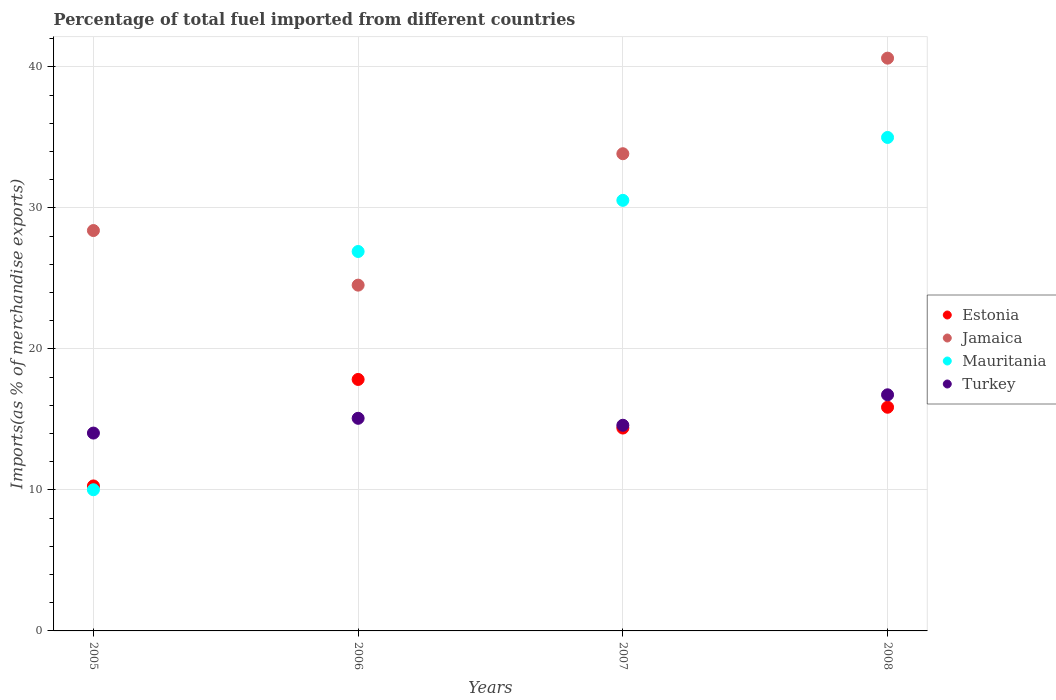What is the percentage of imports to different countries in Estonia in 2006?
Give a very brief answer. 17.83. Across all years, what is the maximum percentage of imports to different countries in Jamaica?
Your answer should be very brief. 40.62. Across all years, what is the minimum percentage of imports to different countries in Jamaica?
Your answer should be compact. 24.52. In which year was the percentage of imports to different countries in Jamaica maximum?
Make the answer very short. 2008. What is the total percentage of imports to different countries in Jamaica in the graph?
Keep it short and to the point. 127.37. What is the difference between the percentage of imports to different countries in Mauritania in 2005 and that in 2007?
Your answer should be very brief. -20.52. What is the difference between the percentage of imports to different countries in Turkey in 2005 and the percentage of imports to different countries in Mauritania in 2008?
Ensure brevity in your answer.  -20.96. What is the average percentage of imports to different countries in Estonia per year?
Give a very brief answer. 14.59. In the year 2007, what is the difference between the percentage of imports to different countries in Mauritania and percentage of imports to different countries in Estonia?
Ensure brevity in your answer.  16.15. What is the ratio of the percentage of imports to different countries in Mauritania in 2006 to that in 2008?
Your answer should be very brief. 0.77. Is the percentage of imports to different countries in Mauritania in 2005 less than that in 2008?
Make the answer very short. Yes. Is the difference between the percentage of imports to different countries in Mauritania in 2006 and 2008 greater than the difference between the percentage of imports to different countries in Estonia in 2006 and 2008?
Give a very brief answer. No. What is the difference between the highest and the second highest percentage of imports to different countries in Turkey?
Ensure brevity in your answer.  1.67. What is the difference between the highest and the lowest percentage of imports to different countries in Turkey?
Give a very brief answer. 2.71. Is it the case that in every year, the sum of the percentage of imports to different countries in Jamaica and percentage of imports to different countries in Turkey  is greater than the sum of percentage of imports to different countries in Mauritania and percentage of imports to different countries in Estonia?
Your answer should be compact. Yes. Is it the case that in every year, the sum of the percentage of imports to different countries in Estonia and percentage of imports to different countries in Turkey  is greater than the percentage of imports to different countries in Mauritania?
Keep it short and to the point. No. Is the percentage of imports to different countries in Estonia strictly less than the percentage of imports to different countries in Mauritania over the years?
Give a very brief answer. No. How many dotlines are there?
Make the answer very short. 4. How many years are there in the graph?
Provide a succinct answer. 4. Does the graph contain any zero values?
Provide a short and direct response. No. Does the graph contain grids?
Offer a very short reply. Yes. What is the title of the graph?
Your answer should be very brief. Percentage of total fuel imported from different countries. What is the label or title of the X-axis?
Offer a terse response. Years. What is the label or title of the Y-axis?
Keep it short and to the point. Imports(as % of merchandise exports). What is the Imports(as % of merchandise exports) of Estonia in 2005?
Your answer should be very brief. 10.28. What is the Imports(as % of merchandise exports) in Jamaica in 2005?
Offer a very short reply. 28.39. What is the Imports(as % of merchandise exports) in Mauritania in 2005?
Offer a very short reply. 10.01. What is the Imports(as % of merchandise exports) in Turkey in 2005?
Offer a terse response. 14.03. What is the Imports(as % of merchandise exports) in Estonia in 2006?
Your response must be concise. 17.83. What is the Imports(as % of merchandise exports) in Jamaica in 2006?
Give a very brief answer. 24.52. What is the Imports(as % of merchandise exports) in Mauritania in 2006?
Provide a succinct answer. 26.91. What is the Imports(as % of merchandise exports) in Turkey in 2006?
Ensure brevity in your answer.  15.08. What is the Imports(as % of merchandise exports) of Estonia in 2007?
Offer a terse response. 14.39. What is the Imports(as % of merchandise exports) in Jamaica in 2007?
Your answer should be very brief. 33.84. What is the Imports(as % of merchandise exports) of Mauritania in 2007?
Keep it short and to the point. 30.53. What is the Imports(as % of merchandise exports) in Turkey in 2007?
Give a very brief answer. 14.58. What is the Imports(as % of merchandise exports) of Estonia in 2008?
Keep it short and to the point. 15.86. What is the Imports(as % of merchandise exports) in Jamaica in 2008?
Make the answer very short. 40.62. What is the Imports(as % of merchandise exports) of Mauritania in 2008?
Ensure brevity in your answer.  34.99. What is the Imports(as % of merchandise exports) in Turkey in 2008?
Give a very brief answer. 16.74. Across all years, what is the maximum Imports(as % of merchandise exports) in Estonia?
Provide a short and direct response. 17.83. Across all years, what is the maximum Imports(as % of merchandise exports) in Jamaica?
Your response must be concise. 40.62. Across all years, what is the maximum Imports(as % of merchandise exports) of Mauritania?
Keep it short and to the point. 34.99. Across all years, what is the maximum Imports(as % of merchandise exports) in Turkey?
Your answer should be compact. 16.74. Across all years, what is the minimum Imports(as % of merchandise exports) in Estonia?
Keep it short and to the point. 10.28. Across all years, what is the minimum Imports(as % of merchandise exports) in Jamaica?
Ensure brevity in your answer.  24.52. Across all years, what is the minimum Imports(as % of merchandise exports) in Mauritania?
Your response must be concise. 10.01. Across all years, what is the minimum Imports(as % of merchandise exports) in Turkey?
Your answer should be compact. 14.03. What is the total Imports(as % of merchandise exports) of Estonia in the graph?
Offer a terse response. 58.36. What is the total Imports(as % of merchandise exports) in Jamaica in the graph?
Offer a terse response. 127.37. What is the total Imports(as % of merchandise exports) of Mauritania in the graph?
Offer a terse response. 102.44. What is the total Imports(as % of merchandise exports) in Turkey in the graph?
Your response must be concise. 60.44. What is the difference between the Imports(as % of merchandise exports) of Estonia in 2005 and that in 2006?
Give a very brief answer. -7.55. What is the difference between the Imports(as % of merchandise exports) of Jamaica in 2005 and that in 2006?
Give a very brief answer. 3.87. What is the difference between the Imports(as % of merchandise exports) of Mauritania in 2005 and that in 2006?
Ensure brevity in your answer.  -16.9. What is the difference between the Imports(as % of merchandise exports) in Turkey in 2005 and that in 2006?
Your response must be concise. -1.05. What is the difference between the Imports(as % of merchandise exports) in Estonia in 2005 and that in 2007?
Your answer should be very brief. -4.11. What is the difference between the Imports(as % of merchandise exports) of Jamaica in 2005 and that in 2007?
Make the answer very short. -5.45. What is the difference between the Imports(as % of merchandise exports) of Mauritania in 2005 and that in 2007?
Offer a terse response. -20.52. What is the difference between the Imports(as % of merchandise exports) in Turkey in 2005 and that in 2007?
Give a very brief answer. -0.55. What is the difference between the Imports(as % of merchandise exports) in Estonia in 2005 and that in 2008?
Give a very brief answer. -5.58. What is the difference between the Imports(as % of merchandise exports) in Jamaica in 2005 and that in 2008?
Offer a terse response. -12.22. What is the difference between the Imports(as % of merchandise exports) in Mauritania in 2005 and that in 2008?
Your response must be concise. -24.98. What is the difference between the Imports(as % of merchandise exports) in Turkey in 2005 and that in 2008?
Offer a terse response. -2.71. What is the difference between the Imports(as % of merchandise exports) of Estonia in 2006 and that in 2007?
Make the answer very short. 3.45. What is the difference between the Imports(as % of merchandise exports) in Jamaica in 2006 and that in 2007?
Your answer should be very brief. -9.32. What is the difference between the Imports(as % of merchandise exports) in Mauritania in 2006 and that in 2007?
Give a very brief answer. -3.63. What is the difference between the Imports(as % of merchandise exports) in Turkey in 2006 and that in 2007?
Offer a terse response. 0.49. What is the difference between the Imports(as % of merchandise exports) in Estonia in 2006 and that in 2008?
Your answer should be very brief. 1.97. What is the difference between the Imports(as % of merchandise exports) in Jamaica in 2006 and that in 2008?
Make the answer very short. -16.1. What is the difference between the Imports(as % of merchandise exports) of Mauritania in 2006 and that in 2008?
Your response must be concise. -8.09. What is the difference between the Imports(as % of merchandise exports) of Turkey in 2006 and that in 2008?
Your answer should be compact. -1.67. What is the difference between the Imports(as % of merchandise exports) in Estonia in 2007 and that in 2008?
Your answer should be compact. -1.48. What is the difference between the Imports(as % of merchandise exports) in Jamaica in 2007 and that in 2008?
Ensure brevity in your answer.  -6.78. What is the difference between the Imports(as % of merchandise exports) in Mauritania in 2007 and that in 2008?
Give a very brief answer. -4.46. What is the difference between the Imports(as % of merchandise exports) in Turkey in 2007 and that in 2008?
Provide a short and direct response. -2.16. What is the difference between the Imports(as % of merchandise exports) in Estonia in 2005 and the Imports(as % of merchandise exports) in Jamaica in 2006?
Ensure brevity in your answer.  -14.24. What is the difference between the Imports(as % of merchandise exports) of Estonia in 2005 and the Imports(as % of merchandise exports) of Mauritania in 2006?
Provide a succinct answer. -16.63. What is the difference between the Imports(as % of merchandise exports) of Estonia in 2005 and the Imports(as % of merchandise exports) of Turkey in 2006?
Your answer should be very brief. -4.8. What is the difference between the Imports(as % of merchandise exports) in Jamaica in 2005 and the Imports(as % of merchandise exports) in Mauritania in 2006?
Your response must be concise. 1.49. What is the difference between the Imports(as % of merchandise exports) of Jamaica in 2005 and the Imports(as % of merchandise exports) of Turkey in 2006?
Keep it short and to the point. 13.31. What is the difference between the Imports(as % of merchandise exports) in Mauritania in 2005 and the Imports(as % of merchandise exports) in Turkey in 2006?
Offer a terse response. -5.07. What is the difference between the Imports(as % of merchandise exports) in Estonia in 2005 and the Imports(as % of merchandise exports) in Jamaica in 2007?
Provide a short and direct response. -23.56. What is the difference between the Imports(as % of merchandise exports) of Estonia in 2005 and the Imports(as % of merchandise exports) of Mauritania in 2007?
Your response must be concise. -20.25. What is the difference between the Imports(as % of merchandise exports) in Estonia in 2005 and the Imports(as % of merchandise exports) in Turkey in 2007?
Your response must be concise. -4.3. What is the difference between the Imports(as % of merchandise exports) in Jamaica in 2005 and the Imports(as % of merchandise exports) in Mauritania in 2007?
Provide a short and direct response. -2.14. What is the difference between the Imports(as % of merchandise exports) in Jamaica in 2005 and the Imports(as % of merchandise exports) in Turkey in 2007?
Offer a terse response. 13.81. What is the difference between the Imports(as % of merchandise exports) of Mauritania in 2005 and the Imports(as % of merchandise exports) of Turkey in 2007?
Give a very brief answer. -4.57. What is the difference between the Imports(as % of merchandise exports) in Estonia in 2005 and the Imports(as % of merchandise exports) in Jamaica in 2008?
Your answer should be compact. -30.34. What is the difference between the Imports(as % of merchandise exports) in Estonia in 2005 and the Imports(as % of merchandise exports) in Mauritania in 2008?
Your answer should be very brief. -24.71. What is the difference between the Imports(as % of merchandise exports) in Estonia in 2005 and the Imports(as % of merchandise exports) in Turkey in 2008?
Give a very brief answer. -6.46. What is the difference between the Imports(as % of merchandise exports) in Jamaica in 2005 and the Imports(as % of merchandise exports) in Mauritania in 2008?
Offer a terse response. -6.6. What is the difference between the Imports(as % of merchandise exports) of Jamaica in 2005 and the Imports(as % of merchandise exports) of Turkey in 2008?
Make the answer very short. 11.65. What is the difference between the Imports(as % of merchandise exports) in Mauritania in 2005 and the Imports(as % of merchandise exports) in Turkey in 2008?
Your response must be concise. -6.73. What is the difference between the Imports(as % of merchandise exports) in Estonia in 2006 and the Imports(as % of merchandise exports) in Jamaica in 2007?
Ensure brevity in your answer.  -16.01. What is the difference between the Imports(as % of merchandise exports) of Estonia in 2006 and the Imports(as % of merchandise exports) of Mauritania in 2007?
Keep it short and to the point. -12.7. What is the difference between the Imports(as % of merchandise exports) of Estonia in 2006 and the Imports(as % of merchandise exports) of Turkey in 2007?
Provide a succinct answer. 3.25. What is the difference between the Imports(as % of merchandise exports) of Jamaica in 2006 and the Imports(as % of merchandise exports) of Mauritania in 2007?
Provide a short and direct response. -6.01. What is the difference between the Imports(as % of merchandise exports) in Jamaica in 2006 and the Imports(as % of merchandise exports) in Turkey in 2007?
Offer a terse response. 9.94. What is the difference between the Imports(as % of merchandise exports) of Mauritania in 2006 and the Imports(as % of merchandise exports) of Turkey in 2007?
Ensure brevity in your answer.  12.32. What is the difference between the Imports(as % of merchandise exports) in Estonia in 2006 and the Imports(as % of merchandise exports) in Jamaica in 2008?
Provide a succinct answer. -22.78. What is the difference between the Imports(as % of merchandise exports) in Estonia in 2006 and the Imports(as % of merchandise exports) in Mauritania in 2008?
Your answer should be very brief. -17.16. What is the difference between the Imports(as % of merchandise exports) in Estonia in 2006 and the Imports(as % of merchandise exports) in Turkey in 2008?
Your response must be concise. 1.09. What is the difference between the Imports(as % of merchandise exports) in Jamaica in 2006 and the Imports(as % of merchandise exports) in Mauritania in 2008?
Ensure brevity in your answer.  -10.47. What is the difference between the Imports(as % of merchandise exports) in Jamaica in 2006 and the Imports(as % of merchandise exports) in Turkey in 2008?
Make the answer very short. 7.78. What is the difference between the Imports(as % of merchandise exports) of Mauritania in 2006 and the Imports(as % of merchandise exports) of Turkey in 2008?
Offer a terse response. 10.16. What is the difference between the Imports(as % of merchandise exports) in Estonia in 2007 and the Imports(as % of merchandise exports) in Jamaica in 2008?
Provide a short and direct response. -26.23. What is the difference between the Imports(as % of merchandise exports) of Estonia in 2007 and the Imports(as % of merchandise exports) of Mauritania in 2008?
Give a very brief answer. -20.61. What is the difference between the Imports(as % of merchandise exports) of Estonia in 2007 and the Imports(as % of merchandise exports) of Turkey in 2008?
Your answer should be compact. -2.36. What is the difference between the Imports(as % of merchandise exports) of Jamaica in 2007 and the Imports(as % of merchandise exports) of Mauritania in 2008?
Make the answer very short. -1.15. What is the difference between the Imports(as % of merchandise exports) in Jamaica in 2007 and the Imports(as % of merchandise exports) in Turkey in 2008?
Offer a terse response. 17.1. What is the difference between the Imports(as % of merchandise exports) of Mauritania in 2007 and the Imports(as % of merchandise exports) of Turkey in 2008?
Your response must be concise. 13.79. What is the average Imports(as % of merchandise exports) of Estonia per year?
Provide a short and direct response. 14.59. What is the average Imports(as % of merchandise exports) of Jamaica per year?
Offer a terse response. 31.84. What is the average Imports(as % of merchandise exports) of Mauritania per year?
Give a very brief answer. 25.61. What is the average Imports(as % of merchandise exports) of Turkey per year?
Give a very brief answer. 15.11. In the year 2005, what is the difference between the Imports(as % of merchandise exports) of Estonia and Imports(as % of merchandise exports) of Jamaica?
Offer a very short reply. -18.11. In the year 2005, what is the difference between the Imports(as % of merchandise exports) in Estonia and Imports(as % of merchandise exports) in Mauritania?
Your response must be concise. 0.27. In the year 2005, what is the difference between the Imports(as % of merchandise exports) of Estonia and Imports(as % of merchandise exports) of Turkey?
Ensure brevity in your answer.  -3.75. In the year 2005, what is the difference between the Imports(as % of merchandise exports) of Jamaica and Imports(as % of merchandise exports) of Mauritania?
Offer a terse response. 18.38. In the year 2005, what is the difference between the Imports(as % of merchandise exports) in Jamaica and Imports(as % of merchandise exports) in Turkey?
Make the answer very short. 14.36. In the year 2005, what is the difference between the Imports(as % of merchandise exports) in Mauritania and Imports(as % of merchandise exports) in Turkey?
Provide a succinct answer. -4.02. In the year 2006, what is the difference between the Imports(as % of merchandise exports) in Estonia and Imports(as % of merchandise exports) in Jamaica?
Your response must be concise. -6.69. In the year 2006, what is the difference between the Imports(as % of merchandise exports) in Estonia and Imports(as % of merchandise exports) in Mauritania?
Your answer should be very brief. -9.07. In the year 2006, what is the difference between the Imports(as % of merchandise exports) in Estonia and Imports(as % of merchandise exports) in Turkey?
Make the answer very short. 2.76. In the year 2006, what is the difference between the Imports(as % of merchandise exports) in Jamaica and Imports(as % of merchandise exports) in Mauritania?
Keep it short and to the point. -2.39. In the year 2006, what is the difference between the Imports(as % of merchandise exports) in Jamaica and Imports(as % of merchandise exports) in Turkey?
Your answer should be very brief. 9.44. In the year 2006, what is the difference between the Imports(as % of merchandise exports) of Mauritania and Imports(as % of merchandise exports) of Turkey?
Give a very brief answer. 11.83. In the year 2007, what is the difference between the Imports(as % of merchandise exports) in Estonia and Imports(as % of merchandise exports) in Jamaica?
Give a very brief answer. -19.45. In the year 2007, what is the difference between the Imports(as % of merchandise exports) of Estonia and Imports(as % of merchandise exports) of Mauritania?
Offer a very short reply. -16.15. In the year 2007, what is the difference between the Imports(as % of merchandise exports) in Estonia and Imports(as % of merchandise exports) in Turkey?
Your answer should be compact. -0.2. In the year 2007, what is the difference between the Imports(as % of merchandise exports) of Jamaica and Imports(as % of merchandise exports) of Mauritania?
Ensure brevity in your answer.  3.31. In the year 2007, what is the difference between the Imports(as % of merchandise exports) in Jamaica and Imports(as % of merchandise exports) in Turkey?
Offer a terse response. 19.26. In the year 2007, what is the difference between the Imports(as % of merchandise exports) of Mauritania and Imports(as % of merchandise exports) of Turkey?
Your response must be concise. 15.95. In the year 2008, what is the difference between the Imports(as % of merchandise exports) of Estonia and Imports(as % of merchandise exports) of Jamaica?
Make the answer very short. -24.75. In the year 2008, what is the difference between the Imports(as % of merchandise exports) of Estonia and Imports(as % of merchandise exports) of Mauritania?
Make the answer very short. -19.13. In the year 2008, what is the difference between the Imports(as % of merchandise exports) of Estonia and Imports(as % of merchandise exports) of Turkey?
Your response must be concise. -0.88. In the year 2008, what is the difference between the Imports(as % of merchandise exports) of Jamaica and Imports(as % of merchandise exports) of Mauritania?
Your answer should be compact. 5.62. In the year 2008, what is the difference between the Imports(as % of merchandise exports) of Jamaica and Imports(as % of merchandise exports) of Turkey?
Offer a terse response. 23.87. In the year 2008, what is the difference between the Imports(as % of merchandise exports) of Mauritania and Imports(as % of merchandise exports) of Turkey?
Offer a very short reply. 18.25. What is the ratio of the Imports(as % of merchandise exports) in Estonia in 2005 to that in 2006?
Provide a succinct answer. 0.58. What is the ratio of the Imports(as % of merchandise exports) of Jamaica in 2005 to that in 2006?
Offer a terse response. 1.16. What is the ratio of the Imports(as % of merchandise exports) of Mauritania in 2005 to that in 2006?
Offer a very short reply. 0.37. What is the ratio of the Imports(as % of merchandise exports) in Turkey in 2005 to that in 2006?
Your answer should be very brief. 0.93. What is the ratio of the Imports(as % of merchandise exports) of Estonia in 2005 to that in 2007?
Your answer should be very brief. 0.71. What is the ratio of the Imports(as % of merchandise exports) in Jamaica in 2005 to that in 2007?
Offer a terse response. 0.84. What is the ratio of the Imports(as % of merchandise exports) in Mauritania in 2005 to that in 2007?
Offer a terse response. 0.33. What is the ratio of the Imports(as % of merchandise exports) in Turkey in 2005 to that in 2007?
Provide a succinct answer. 0.96. What is the ratio of the Imports(as % of merchandise exports) of Estonia in 2005 to that in 2008?
Provide a short and direct response. 0.65. What is the ratio of the Imports(as % of merchandise exports) in Jamaica in 2005 to that in 2008?
Your answer should be compact. 0.7. What is the ratio of the Imports(as % of merchandise exports) of Mauritania in 2005 to that in 2008?
Make the answer very short. 0.29. What is the ratio of the Imports(as % of merchandise exports) in Turkey in 2005 to that in 2008?
Provide a succinct answer. 0.84. What is the ratio of the Imports(as % of merchandise exports) in Estonia in 2006 to that in 2007?
Offer a terse response. 1.24. What is the ratio of the Imports(as % of merchandise exports) in Jamaica in 2006 to that in 2007?
Your answer should be compact. 0.72. What is the ratio of the Imports(as % of merchandise exports) in Mauritania in 2006 to that in 2007?
Offer a terse response. 0.88. What is the ratio of the Imports(as % of merchandise exports) in Turkey in 2006 to that in 2007?
Provide a succinct answer. 1.03. What is the ratio of the Imports(as % of merchandise exports) of Estonia in 2006 to that in 2008?
Offer a very short reply. 1.12. What is the ratio of the Imports(as % of merchandise exports) in Jamaica in 2006 to that in 2008?
Provide a succinct answer. 0.6. What is the ratio of the Imports(as % of merchandise exports) of Mauritania in 2006 to that in 2008?
Provide a short and direct response. 0.77. What is the ratio of the Imports(as % of merchandise exports) in Turkey in 2006 to that in 2008?
Provide a short and direct response. 0.9. What is the ratio of the Imports(as % of merchandise exports) in Estonia in 2007 to that in 2008?
Your answer should be compact. 0.91. What is the ratio of the Imports(as % of merchandise exports) in Jamaica in 2007 to that in 2008?
Your answer should be compact. 0.83. What is the ratio of the Imports(as % of merchandise exports) in Mauritania in 2007 to that in 2008?
Your answer should be compact. 0.87. What is the ratio of the Imports(as % of merchandise exports) of Turkey in 2007 to that in 2008?
Your response must be concise. 0.87. What is the difference between the highest and the second highest Imports(as % of merchandise exports) of Estonia?
Ensure brevity in your answer.  1.97. What is the difference between the highest and the second highest Imports(as % of merchandise exports) of Jamaica?
Provide a succinct answer. 6.78. What is the difference between the highest and the second highest Imports(as % of merchandise exports) in Mauritania?
Offer a very short reply. 4.46. What is the difference between the highest and the second highest Imports(as % of merchandise exports) in Turkey?
Provide a succinct answer. 1.67. What is the difference between the highest and the lowest Imports(as % of merchandise exports) of Estonia?
Offer a terse response. 7.55. What is the difference between the highest and the lowest Imports(as % of merchandise exports) of Jamaica?
Offer a very short reply. 16.1. What is the difference between the highest and the lowest Imports(as % of merchandise exports) in Mauritania?
Provide a short and direct response. 24.98. What is the difference between the highest and the lowest Imports(as % of merchandise exports) of Turkey?
Keep it short and to the point. 2.71. 